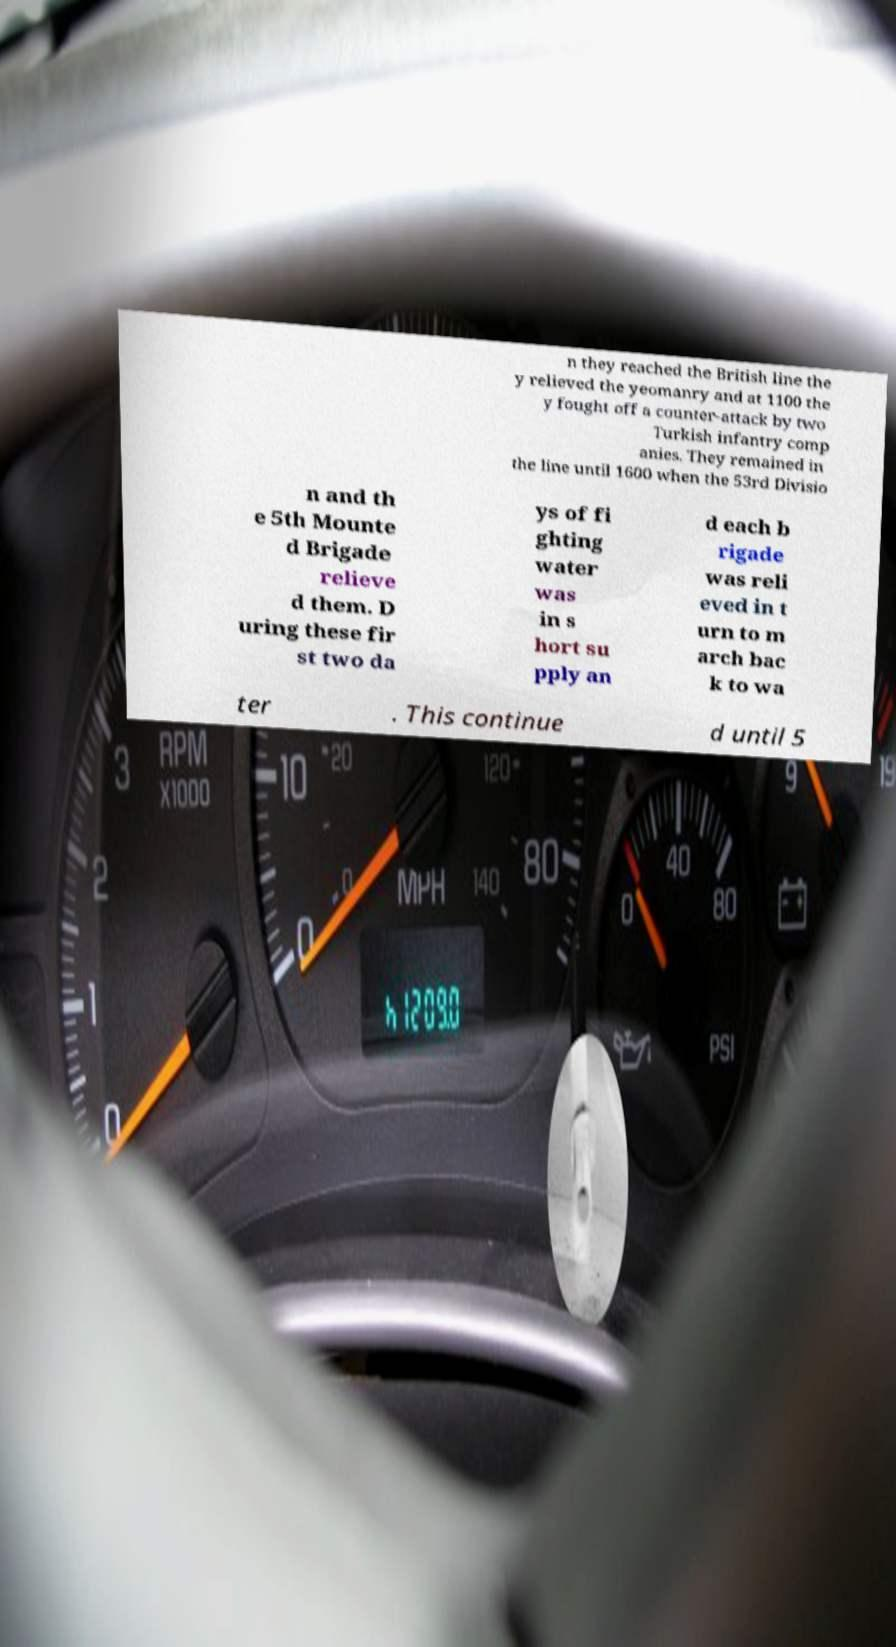Can you accurately transcribe the text from the provided image for me? n they reached the British line the y relieved the yeomanry and at 1100 the y fought off a counter-attack by two Turkish infantry comp anies. They remained in the line until 1600 when the 53rd Divisio n and th e 5th Mounte d Brigade relieve d them. D uring these fir st two da ys of fi ghting water was in s hort su pply an d each b rigade was reli eved in t urn to m arch bac k to wa ter . This continue d until 5 